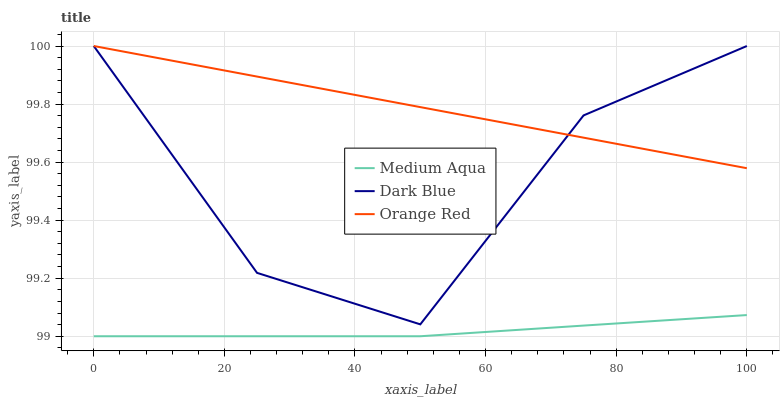Does Orange Red have the minimum area under the curve?
Answer yes or no. No. Does Medium Aqua have the maximum area under the curve?
Answer yes or no. No. Is Medium Aqua the smoothest?
Answer yes or no. No. Is Medium Aqua the roughest?
Answer yes or no. No. Does Orange Red have the lowest value?
Answer yes or no. No. Does Medium Aqua have the highest value?
Answer yes or no. No. Is Medium Aqua less than Dark Blue?
Answer yes or no. Yes. Is Dark Blue greater than Medium Aqua?
Answer yes or no. Yes. Does Medium Aqua intersect Dark Blue?
Answer yes or no. No. 